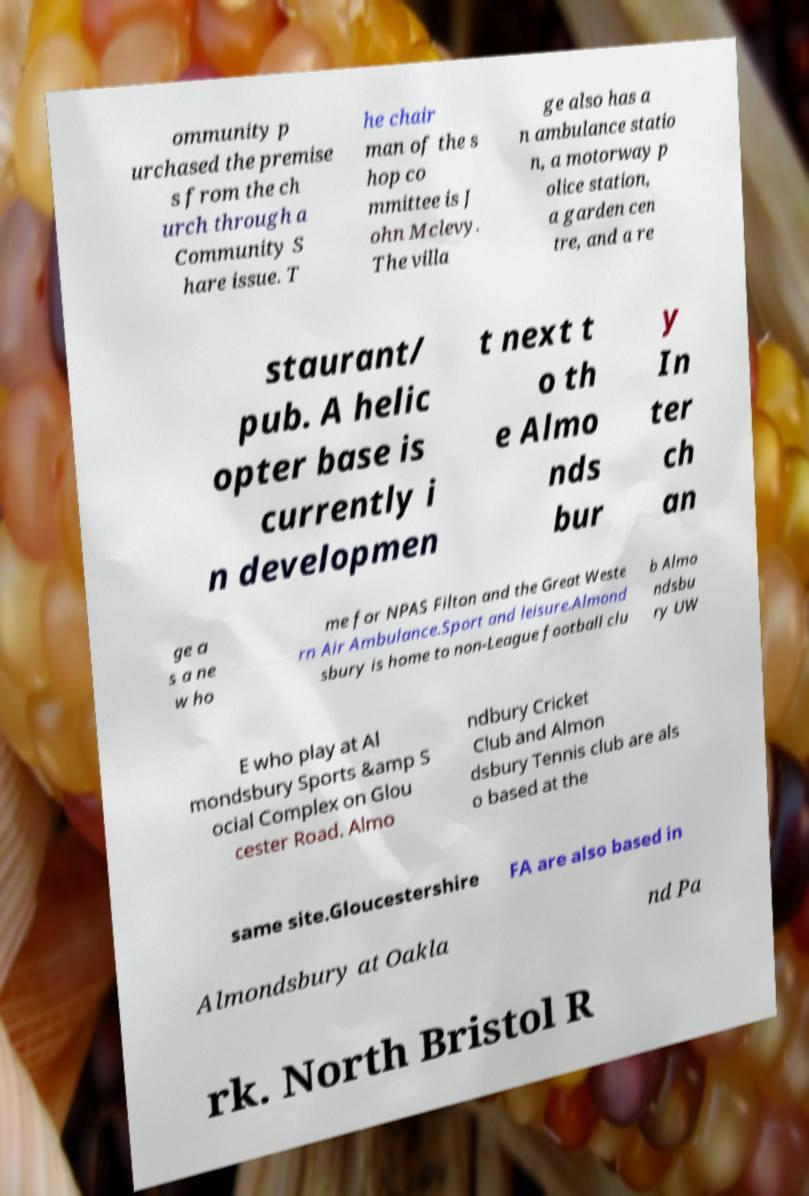What messages or text are displayed in this image? I need them in a readable, typed format. ommunity p urchased the premise s from the ch urch through a Community S hare issue. T he chair man of the s hop co mmittee is J ohn Mclevy. The villa ge also has a n ambulance statio n, a motorway p olice station, a garden cen tre, and a re staurant/ pub. A helic opter base is currently i n developmen t next t o th e Almo nds bur y In ter ch an ge a s a ne w ho me for NPAS Filton and the Great Weste rn Air Ambulance.Sport and leisure.Almond sbury is home to non-League football clu b Almo ndsbu ry UW E who play at Al mondsbury Sports &amp S ocial Complex on Glou cester Road. Almo ndbury Cricket Club and Almon dsbury Tennis club are als o based at the same site.Gloucestershire FA are also based in Almondsbury at Oakla nd Pa rk. North Bristol R 